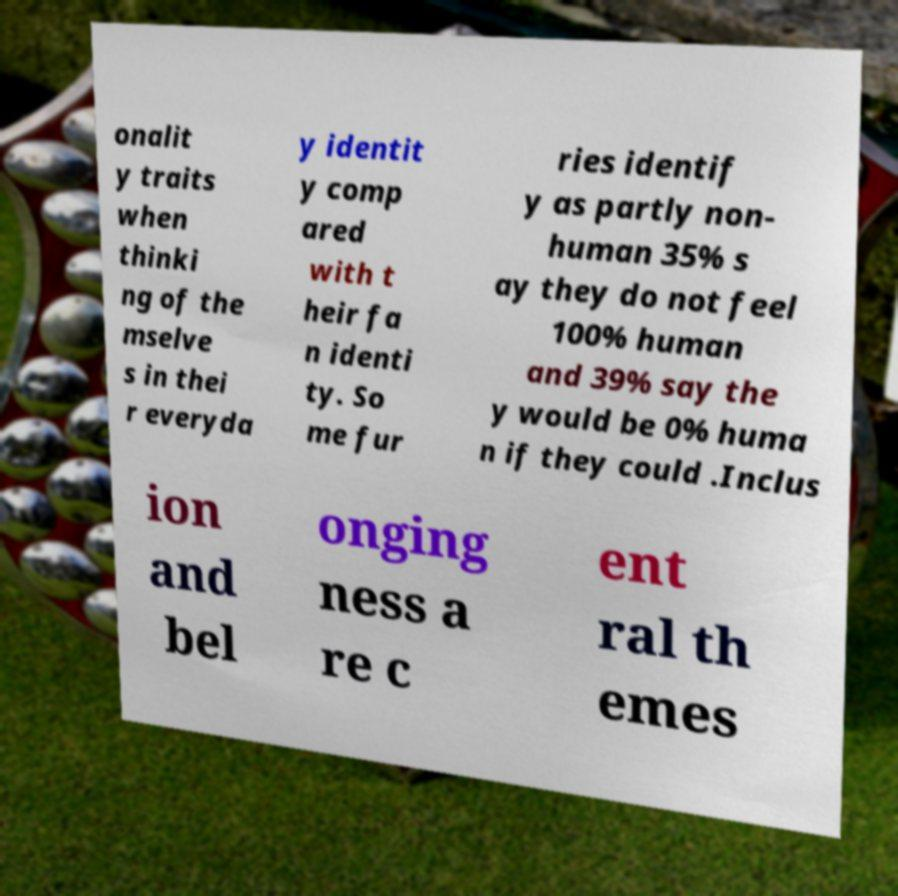Please identify and transcribe the text found in this image. onalit y traits when thinki ng of the mselve s in thei r everyda y identit y comp ared with t heir fa n identi ty. So me fur ries identif y as partly non- human 35% s ay they do not feel 100% human and 39% say the y would be 0% huma n if they could .Inclus ion and bel onging ness a re c ent ral th emes 